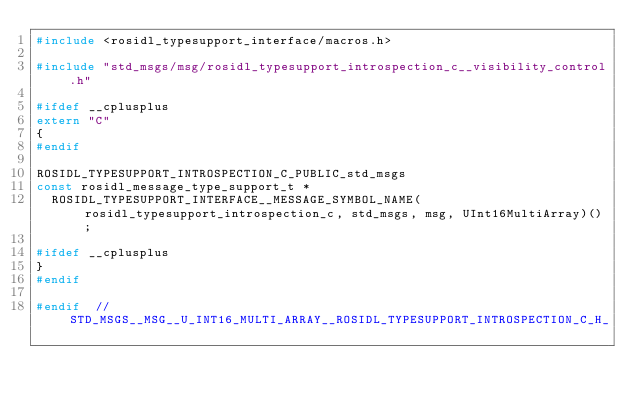<code> <loc_0><loc_0><loc_500><loc_500><_C_>#include <rosidl_typesupport_interface/macros.h>

#include "std_msgs/msg/rosidl_typesupport_introspection_c__visibility_control.h"

#ifdef __cplusplus
extern "C"
{
#endif

ROSIDL_TYPESUPPORT_INTROSPECTION_C_PUBLIC_std_msgs
const rosidl_message_type_support_t *
  ROSIDL_TYPESUPPORT_INTERFACE__MESSAGE_SYMBOL_NAME(rosidl_typesupport_introspection_c, std_msgs, msg, UInt16MultiArray)();

#ifdef __cplusplus
}
#endif

#endif  // STD_MSGS__MSG__U_INT16_MULTI_ARRAY__ROSIDL_TYPESUPPORT_INTROSPECTION_C_H_
</code> 